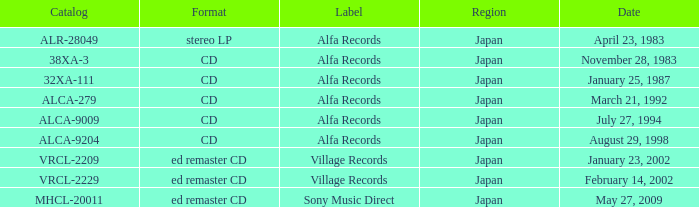Which date is in stereo lp format? April 23, 1983. I'm looking to parse the entire table for insights. Could you assist me with that? {'header': ['Catalog', 'Format', 'Label', 'Region', 'Date'], 'rows': [['ALR-28049', 'stereo LP', 'Alfa Records', 'Japan', 'April 23, 1983'], ['38XA-3', 'CD', 'Alfa Records', 'Japan', 'November 28, 1983'], ['32XA-111', 'CD', 'Alfa Records', 'Japan', 'January 25, 1987'], ['ALCA-279', 'CD', 'Alfa Records', 'Japan', 'March 21, 1992'], ['ALCA-9009', 'CD', 'Alfa Records', 'Japan', 'July 27, 1994'], ['ALCA-9204', 'CD', 'Alfa Records', 'Japan', 'August 29, 1998'], ['VRCL-2209', 'ed remaster CD', 'Village Records', 'Japan', 'January 23, 2002'], ['VRCL-2229', 'ed remaster CD', 'Village Records', 'Japan', 'February 14, 2002'], ['MHCL-20011', 'ed remaster CD', 'Sony Music Direct', 'Japan', 'May 27, 2009']]} 